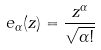Convert formula to latex. <formula><loc_0><loc_0><loc_500><loc_500>e _ { \alpha } ( z ) = \frac { z ^ { \alpha } } { \sqrt { \alpha ! } }</formula> 